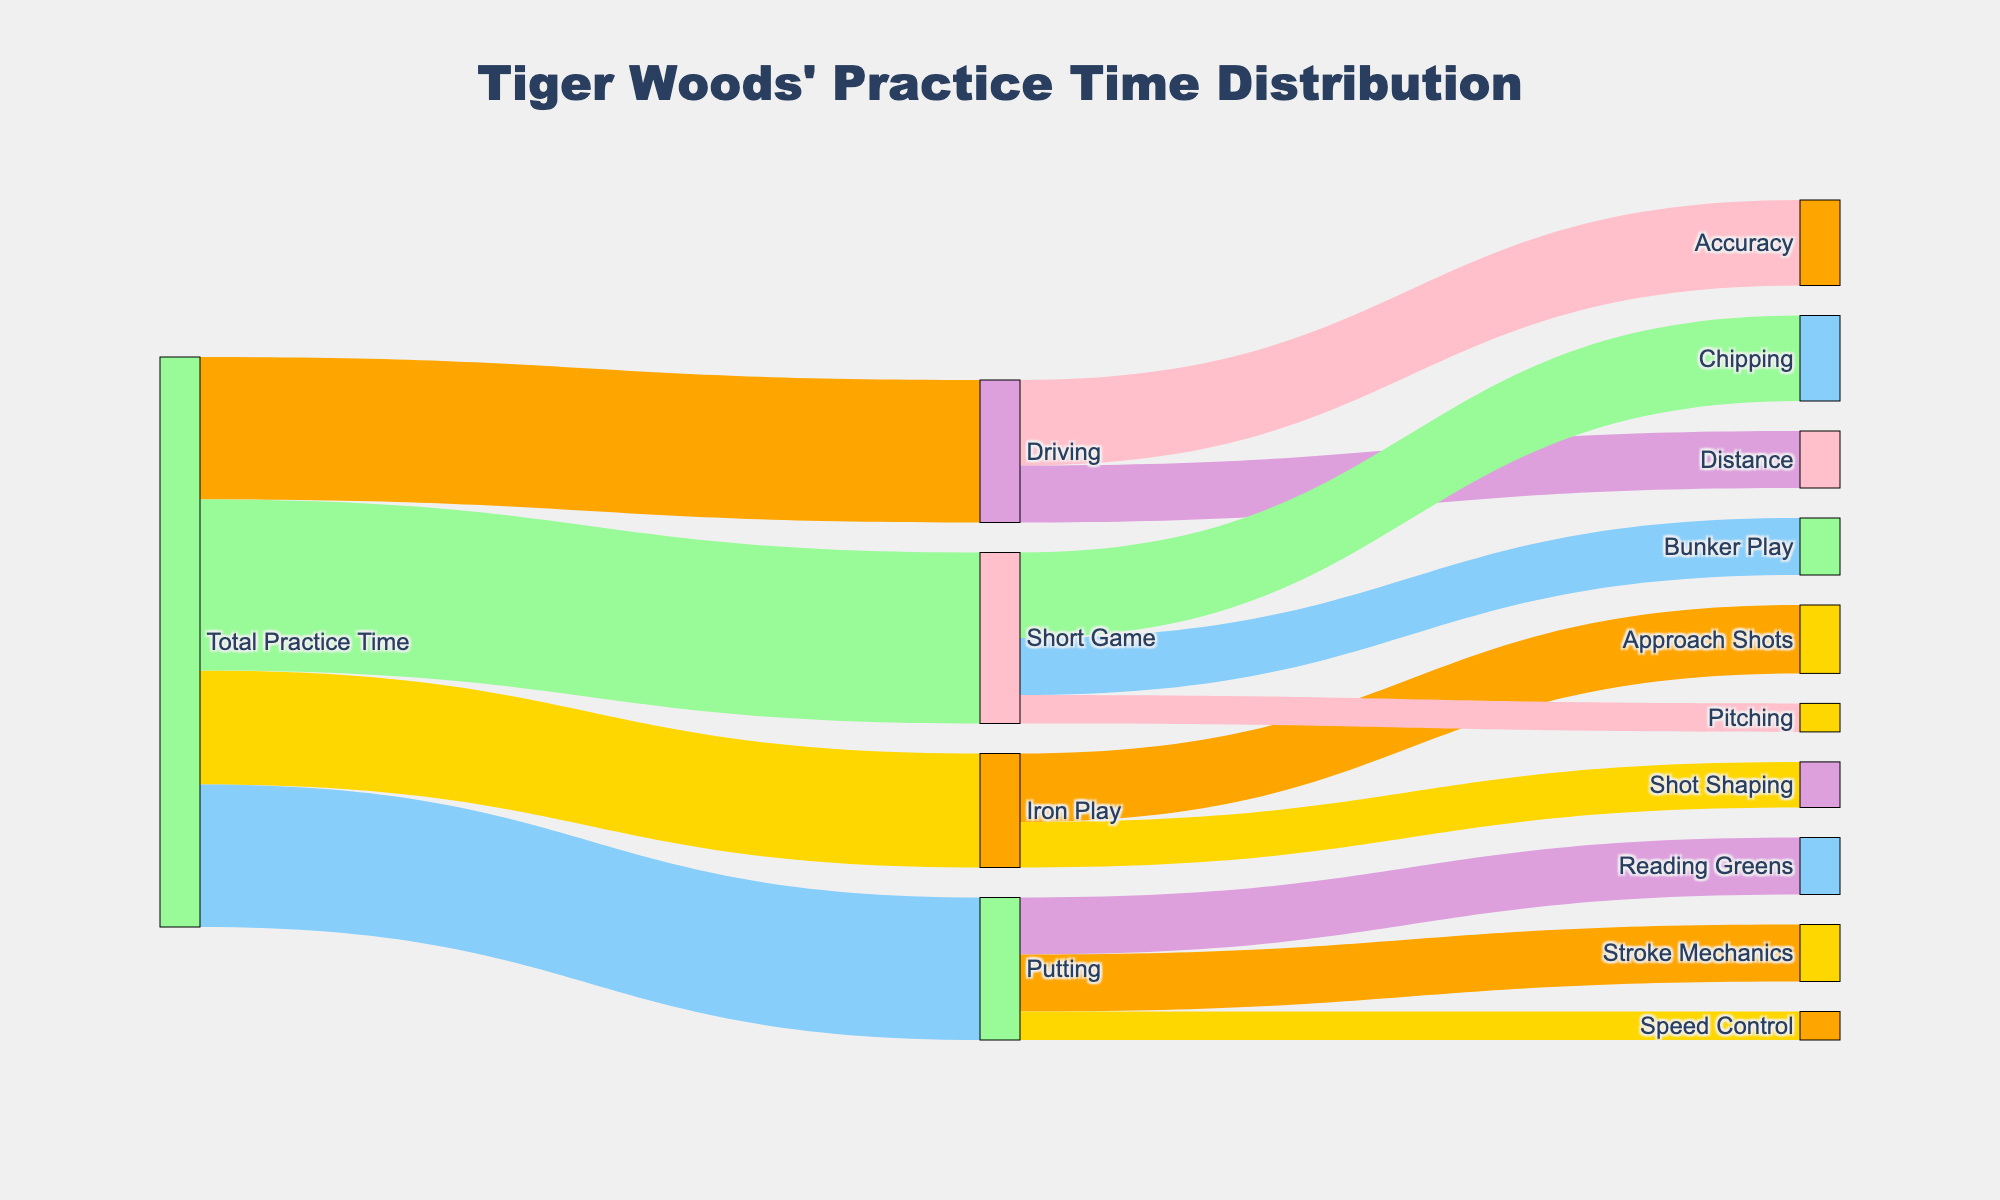What is the title of the Sankey Diagram? The title of the diagram is shown prominently at the top of the figure.
Answer: "Tiger Woods' Practice Time Distribution" What is the total practice time Tiger Woods spends on Putting? The value indicating the practice time for Putting can be found connected to "Total Practice Time" in the diagram.
Answer: 25 Which area does Tiger Woods spend the most practice time on, and how much time does he spend? By comparing the values directly connected to "Total Practice Time," the highest value indicates the area with the most practice time.
Answer: Short Game, 30 How much more time does Tiger Woods spend on Driving than Iron Play? Subtract the time spent on Iron Play from the time spent on Driving: 25 - 20 = 5.
Answer: 5 What is the practice time distribution within the Short Game category? Follow the links from Short Game to its subcategories to find and add the values: Chipping (15), Bunker Play (10), and Pitching (5).
Answer: 15 for Chipping, 10 for Bunker Play, 5 for Pitching Which subcategory within Driving does Tiger Woods spend more time on? Compare the values connected to the subcategories of Driving: Accuracy and Distance.
Answer: Accuracy What is the sum of practice time on Accuracy and Distance? Add the values of Accuracy and Distance within the Driving category: 15 + 10 = 25.
Answer: 25 How does the practice time on Stroke Mechanics compare to Reading Greens in Putting? Directly compare the values connected to Putting: both Reading Greens and Stroke Mechanics have their respective values.
Answer: They are equal What is the total amount of Tiger Woods' practice time devoted to different types of Short Game skills? Sum the individual practice times of Chipping, Bunker Play, and Pitching: 15 + 10 + 5 = 30.
Answer: 30 On which category and subcategory does Tiger Woods spend exactly 10 units of practice time? Check the diagram for instances where the value is 10 units for connections: Bunker Play, Distance, Stroke Mechanics, and Reading Greens.
Answer: Bunker Play, Distance, Stroke Mechanics, Reading Greens 